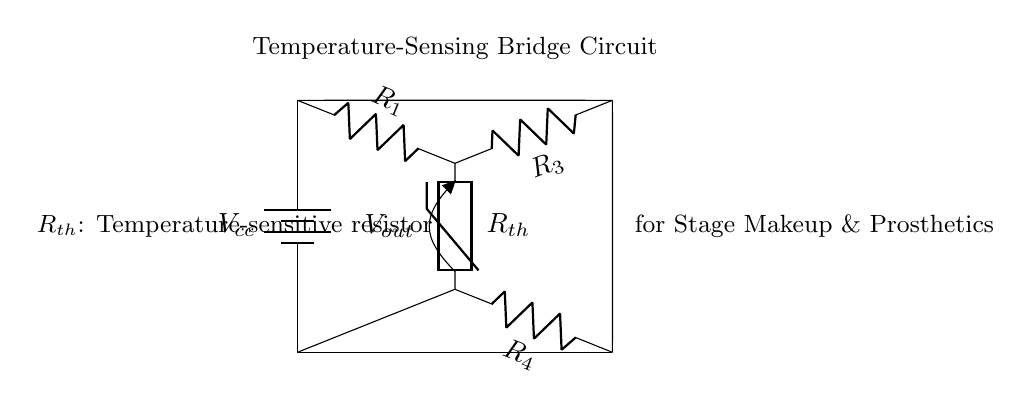What is the voltage source in this circuit? The circuit contains a battery labeled as Vcc, which serves as the voltage source providing power to the circuit.
Answer: Vcc What type of resistor is represented by Rth? Rth represents a thermistor, which is a temperature-sensitive resistor that changes resistance based on temperature changes.
Answer: Thermistor How many resistors are in the bridge circuit? The bridge circuit consists of four resistors in total: R1, R3, R4, and Rth.
Answer: Four What is the purpose of the output voltage Vout? Vout provides the measurement of the voltage difference in the bridge circuit, which indicates changes based on the temperature sensed by Rth.
Answer: Measure temperature Which resistors are on the left side of the bridge? The left side of the bridge contains two resistors: R1 and Rth.
Answer: R1 and Rth Why is Rth used in a temperature-sensing bridge? Rth is used because it responds to temperature changes, allowing the bridge circuit to monitor heat levels in stage makeup and prosthetics effectively.
Answer: To sense temperature 